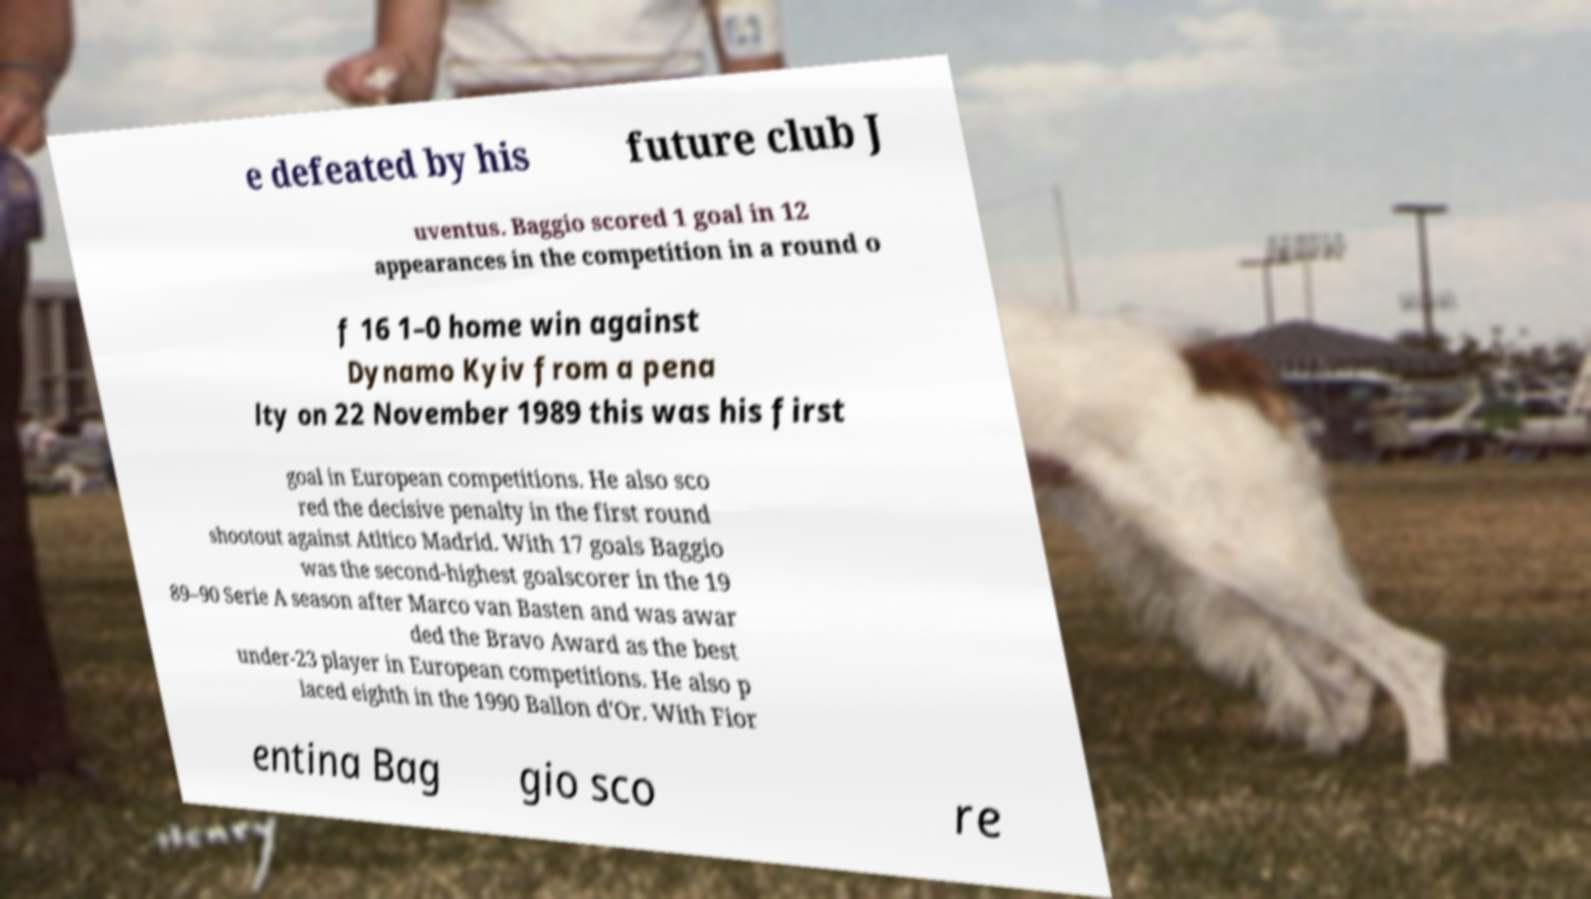Please read and relay the text visible in this image. What does it say? e defeated by his future club J uventus. Baggio scored 1 goal in 12 appearances in the competition in a round o f 16 1–0 home win against Dynamo Kyiv from a pena lty on 22 November 1989 this was his first goal in European competitions. He also sco red the decisive penalty in the first round shootout against Atltico Madrid. With 17 goals Baggio was the second-highest goalscorer in the 19 89–90 Serie A season after Marco van Basten and was awar ded the Bravo Award as the best under-23 player in European competitions. He also p laced eighth in the 1990 Ballon d'Or. With Fior entina Bag gio sco re 